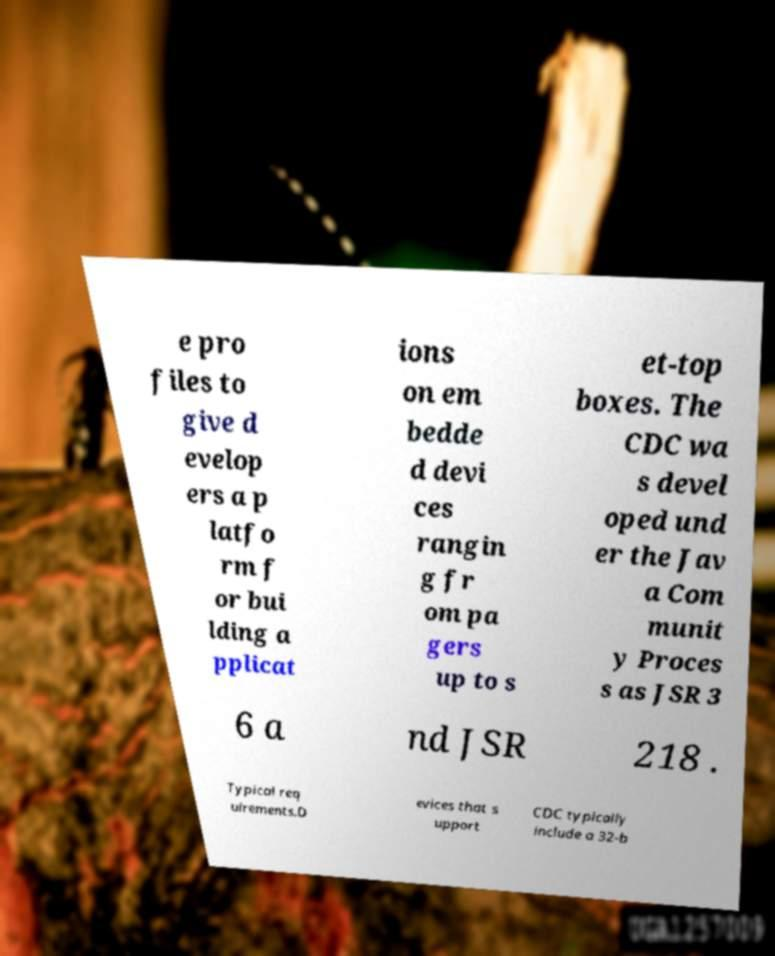What messages or text are displayed in this image? I need them in a readable, typed format. e pro files to give d evelop ers a p latfo rm f or bui lding a pplicat ions on em bedde d devi ces rangin g fr om pa gers up to s et-top boxes. The CDC wa s devel oped und er the Jav a Com munit y Proces s as JSR 3 6 a nd JSR 218 . Typical req uirements.D evices that s upport CDC typically include a 32-b 